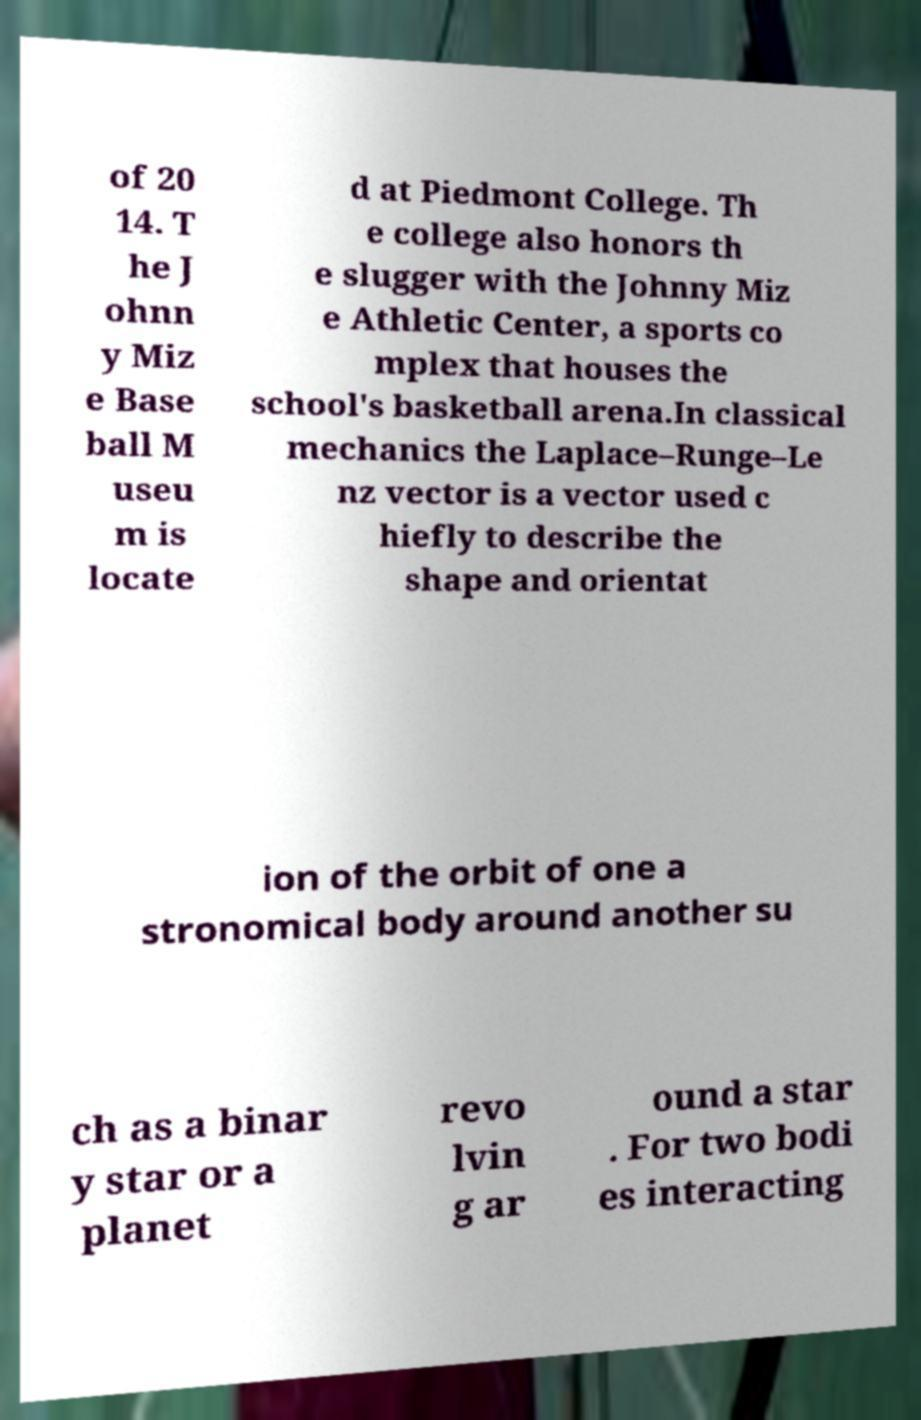There's text embedded in this image that I need extracted. Can you transcribe it verbatim? of 20 14. T he J ohnn y Miz e Base ball M useu m is locate d at Piedmont College. Th e college also honors th e slugger with the Johnny Miz e Athletic Center, a sports co mplex that houses the school's basketball arena.In classical mechanics the Laplace–Runge–Le nz vector is a vector used c hiefly to describe the shape and orientat ion of the orbit of one a stronomical body around another su ch as a binar y star or a planet revo lvin g ar ound a star . For two bodi es interacting 